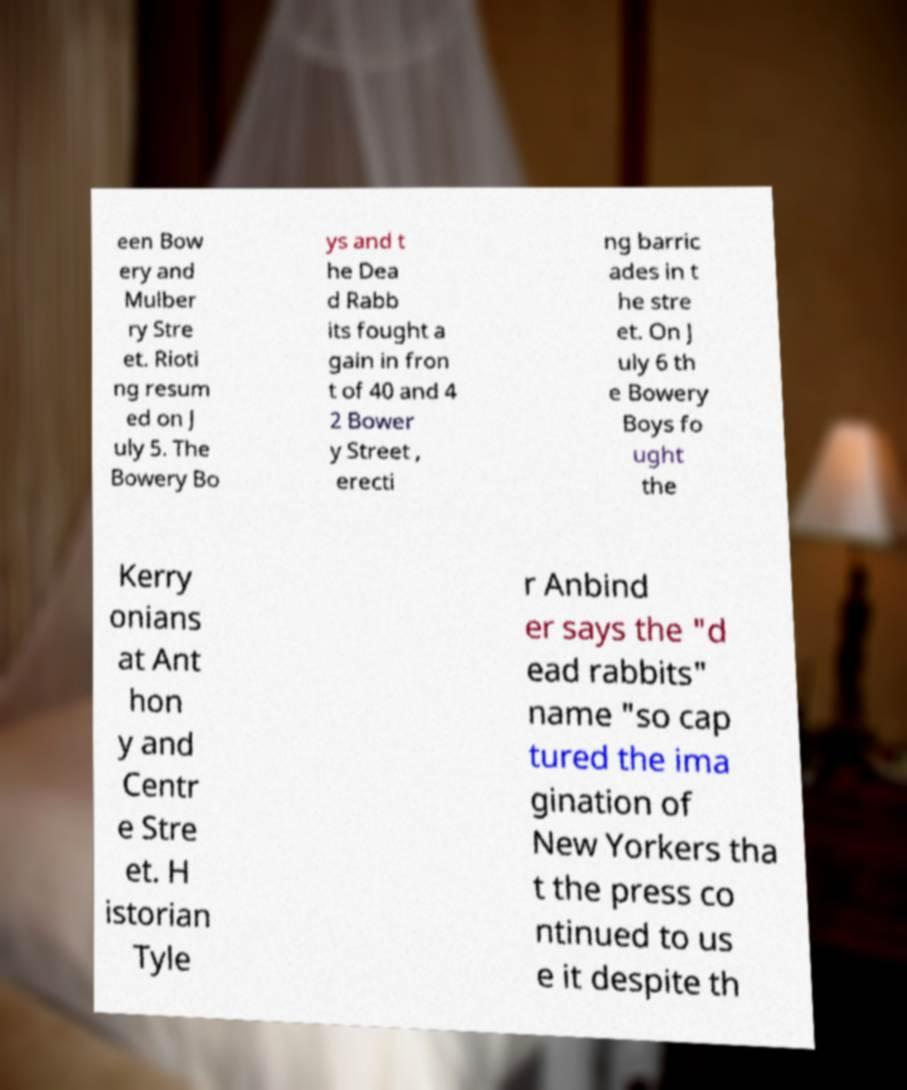Please read and relay the text visible in this image. What does it say? een Bow ery and Mulber ry Stre et. Rioti ng resum ed on J uly 5. The Bowery Bo ys and t he Dea d Rabb its fought a gain in fron t of 40 and 4 2 Bower y Street , erecti ng barric ades in t he stre et. On J uly 6 th e Bowery Boys fo ught the Kerry onians at Ant hon y and Centr e Stre et. H istorian Tyle r Anbind er says the "d ead rabbits" name "so cap tured the ima gination of New Yorkers tha t the press co ntinued to us e it despite th 